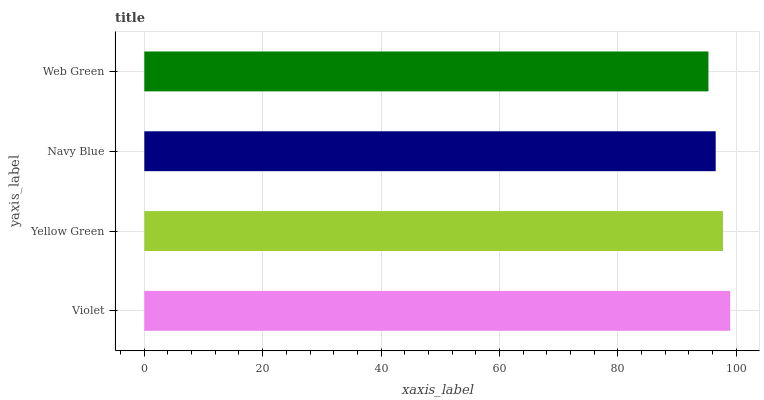Is Web Green the minimum?
Answer yes or no. Yes. Is Violet the maximum?
Answer yes or no. Yes. Is Yellow Green the minimum?
Answer yes or no. No. Is Yellow Green the maximum?
Answer yes or no. No. Is Violet greater than Yellow Green?
Answer yes or no. Yes. Is Yellow Green less than Violet?
Answer yes or no. Yes. Is Yellow Green greater than Violet?
Answer yes or no. No. Is Violet less than Yellow Green?
Answer yes or no. No. Is Yellow Green the high median?
Answer yes or no. Yes. Is Navy Blue the low median?
Answer yes or no. Yes. Is Web Green the high median?
Answer yes or no. No. Is Violet the low median?
Answer yes or no. No. 